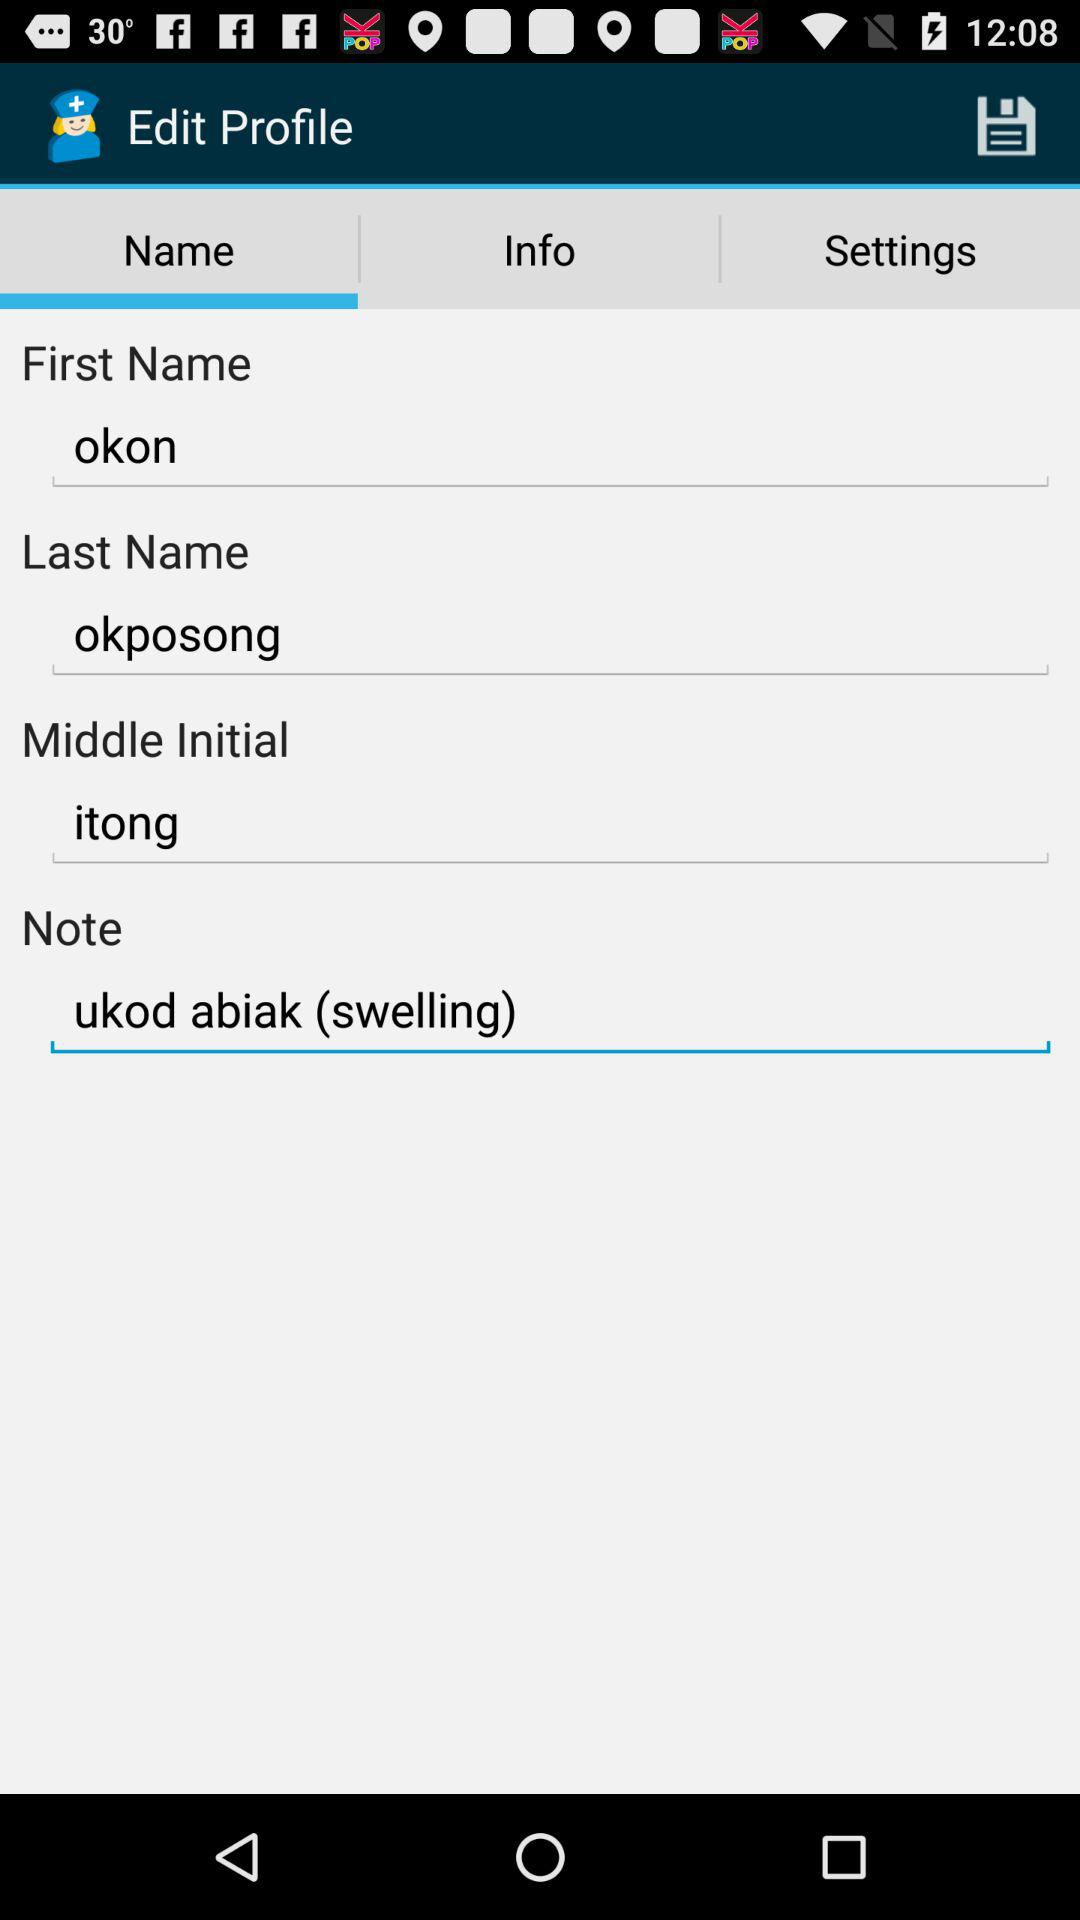What is in the note? In the note it is "ukod abiak (swelling)". 